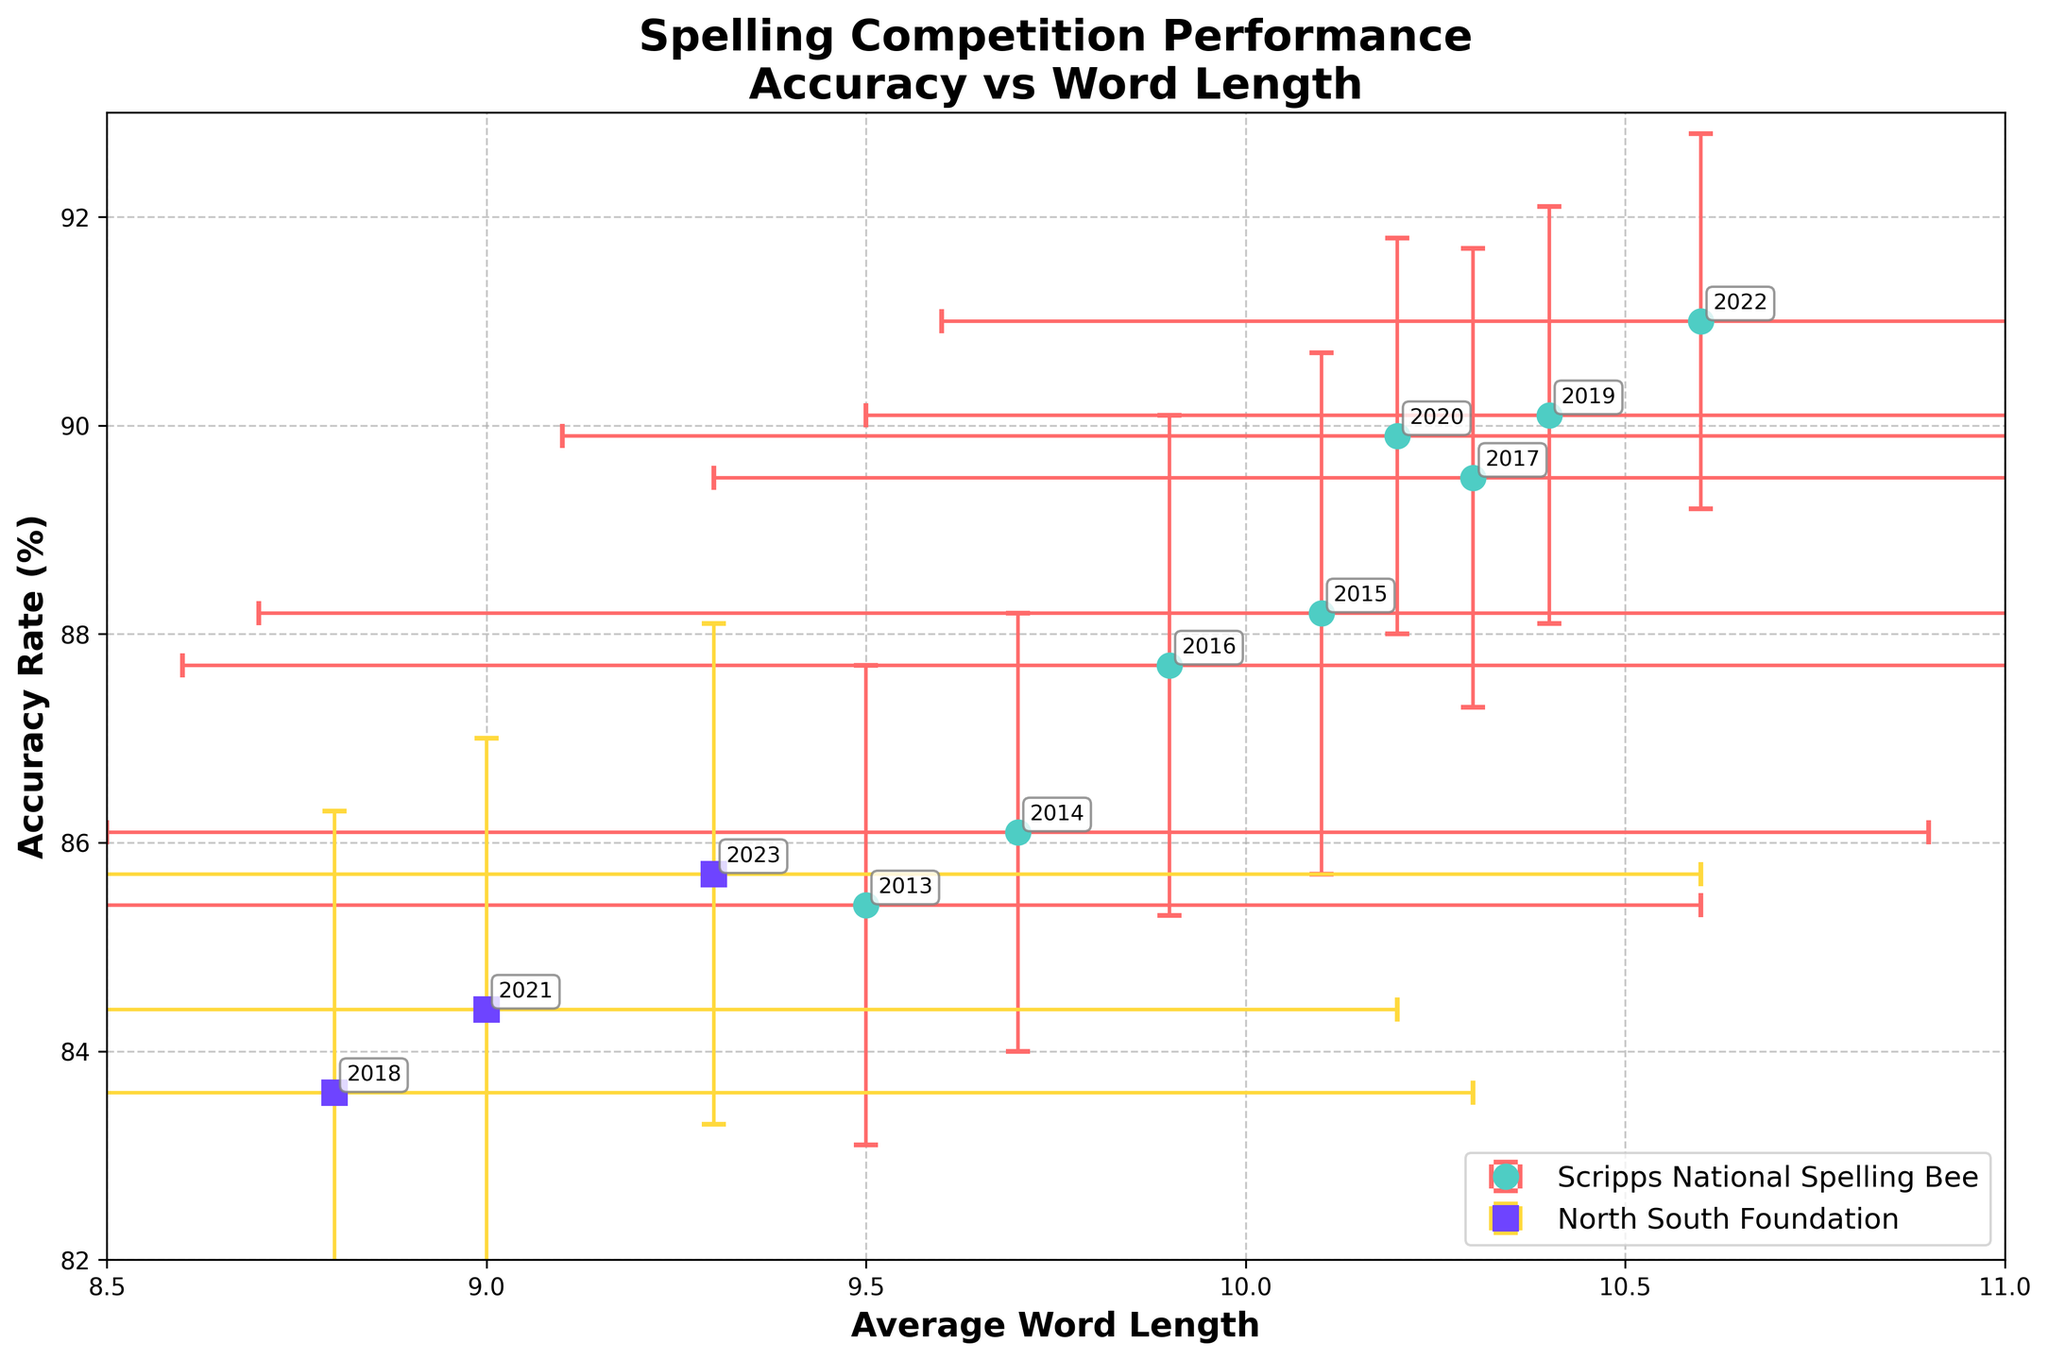How many total data points are represented for the Scripps National Spelling Bee? There are individual markers for each year labeled as "Scripps National Spelling Bee". By counting these markers, we can see there are 8 data points for this competition.
Answer: 8 What's the range of average word lengths seen in the Scripps National Spelling Bee from 2013 to 2023? The smallest average word length for the Scripps National Spelling Bee is 9.5 in 2013, and the largest is 10.6 in 2022. Therefore, the range is 10.6 - 9.5 = 1.1.
Answer: 1.1 Which year had the highest accuracy rate in the North South Foundation? The data points for each year are labeled. By checking the North South Foundation markers, the highest accuracy rate is 85.7% in the year 2023.
Answer: 2023 What is the average accuracy rate for the North South Foundation over the years shown? The accuracy rates for North South Foundation are 83.6%, 84.4%, and 85.7%. The average is (83.6 + 84.4 + 85.7) / 3 = 84.57 (rounded to two decimal places).
Answer: 84.57 How did the average word length change from 2018 to 2021 in the North South Foundation? For North South Foundation, the average word length changed from 8.8 in 2018 to 9.0 in 2021. The difference is 9.0 - 8.8 = 0.2.
Answer: 0.2 Which competition generally had higher accuracy rates - Scripps National Spelling Bee or North South Foundation? By observing the plotted points, the Scripps National Spelling Bee generally has higher accuracy rates as its points are mostly higher up on the y-axis compared to the North South Foundation points.
Answer: Scripps National Spelling Bee In which year did the Scripps National Spelling Bee have the smallest standard deviation for accuracy rate? By checking the error bars in the vertical direction for each year of Scripps National Spelling Bee, the smallest standard deviation (narrowest error bar) is in 2022 with 1.8.
Answer: 2022 What years do the markers correspond to for the highest and lowest average word lengths in the Scripps National Spelling Bee? The highest average word length for Scripps National Spelling Bee is 10.6 in 2022, while the lowest is 9.5 in 2013.
Answer: 2022 and 2013 (respectively) How does the variability in average word length compare between the two competitions? By examining the horizontal error bars, which represent the standard deviation of word length, North South Foundation generally shows larger error bars, suggesting higher variability compared to the Scripps National Spelling Bee.
Answer: North South Foundation has higher variability 